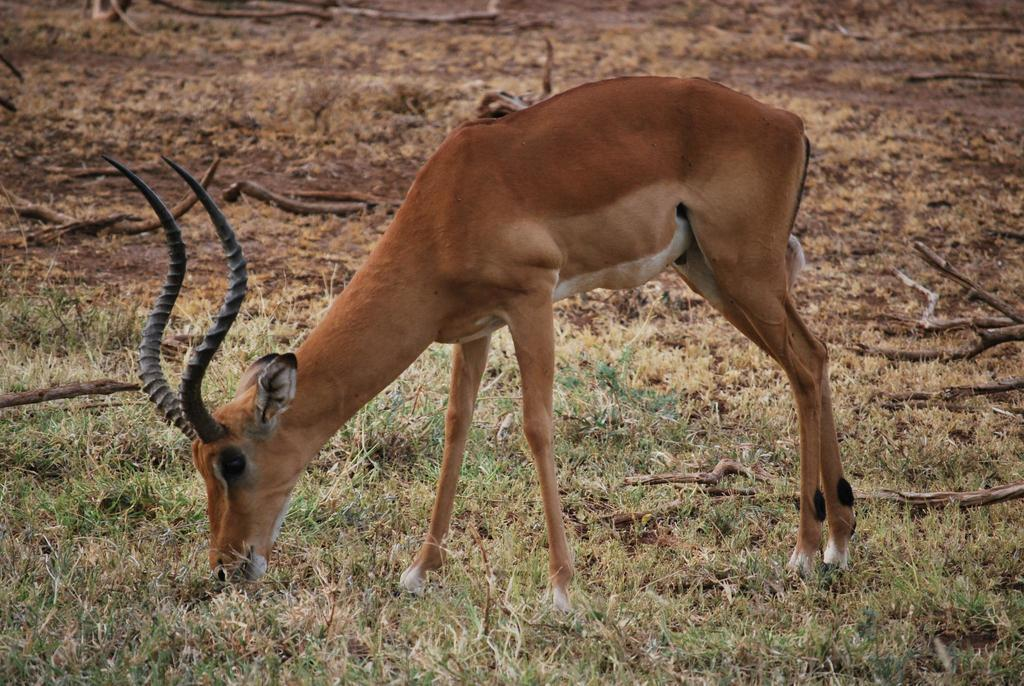What animals can be seen in the image? There are deer in the image. Where are the deer located? The deer are on the grass. What can be seen in the background of the image? There are twigs visible in the background of the image. What type of bulb is hanging from the tree in the image? There is no bulb present in the image; it features deer on the grass with twigs visible in the background. 